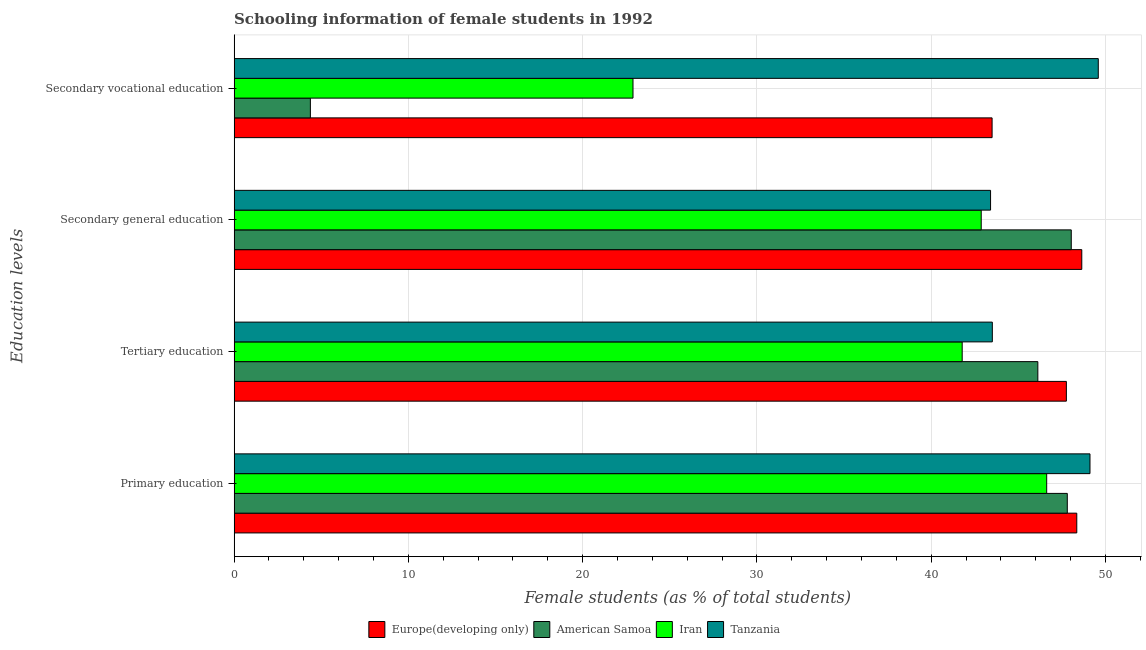How many different coloured bars are there?
Provide a short and direct response. 4. Are the number of bars per tick equal to the number of legend labels?
Give a very brief answer. Yes. What is the label of the 3rd group of bars from the top?
Your answer should be compact. Tertiary education. What is the percentage of female students in tertiary education in Iran?
Your response must be concise. 41.77. Across all countries, what is the maximum percentage of female students in secondary education?
Your answer should be very brief. 48.64. Across all countries, what is the minimum percentage of female students in tertiary education?
Offer a very short reply. 41.77. In which country was the percentage of female students in primary education maximum?
Your answer should be compact. Tanzania. In which country was the percentage of female students in primary education minimum?
Give a very brief answer. Iran. What is the total percentage of female students in tertiary education in the graph?
Ensure brevity in your answer.  179.15. What is the difference between the percentage of female students in tertiary education in Iran and that in American Samoa?
Ensure brevity in your answer.  -4.34. What is the difference between the percentage of female students in tertiary education in Europe(developing only) and the percentage of female students in secondary education in American Samoa?
Give a very brief answer. -0.28. What is the average percentage of female students in secondary education per country?
Keep it short and to the point. 45.73. What is the difference between the percentage of female students in secondary vocational education and percentage of female students in secondary education in Tanzania?
Your answer should be compact. 6.18. What is the ratio of the percentage of female students in secondary education in Iran to that in American Samoa?
Your answer should be very brief. 0.89. Is the percentage of female students in secondary vocational education in Tanzania less than that in American Samoa?
Offer a terse response. No. Is the difference between the percentage of female students in secondary education in American Samoa and Iran greater than the difference between the percentage of female students in secondary vocational education in American Samoa and Iran?
Keep it short and to the point. Yes. What is the difference between the highest and the second highest percentage of female students in secondary vocational education?
Your response must be concise. 6.09. What is the difference between the highest and the lowest percentage of female students in tertiary education?
Your answer should be very brief. 5.98. Is the sum of the percentage of female students in primary education in Iran and American Samoa greater than the maximum percentage of female students in secondary education across all countries?
Provide a succinct answer. Yes. What does the 1st bar from the top in Secondary general education represents?
Make the answer very short. Tanzania. What does the 2nd bar from the bottom in Tertiary education represents?
Provide a succinct answer. American Samoa. Is it the case that in every country, the sum of the percentage of female students in primary education and percentage of female students in tertiary education is greater than the percentage of female students in secondary education?
Provide a short and direct response. Yes. How many bars are there?
Your response must be concise. 16. Are all the bars in the graph horizontal?
Your answer should be very brief. Yes. How many countries are there in the graph?
Your response must be concise. 4. What is the difference between two consecutive major ticks on the X-axis?
Keep it short and to the point. 10. Does the graph contain grids?
Your answer should be compact. Yes. Where does the legend appear in the graph?
Make the answer very short. Bottom center. How many legend labels are there?
Ensure brevity in your answer.  4. What is the title of the graph?
Offer a very short reply. Schooling information of female students in 1992. Does "Cameroon" appear as one of the legend labels in the graph?
Offer a terse response. No. What is the label or title of the X-axis?
Provide a succinct answer. Female students (as % of total students). What is the label or title of the Y-axis?
Provide a succinct answer. Education levels. What is the Female students (as % of total students) of Europe(developing only) in Primary education?
Make the answer very short. 48.35. What is the Female students (as % of total students) in American Samoa in Primary education?
Offer a terse response. 47.81. What is the Female students (as % of total students) in Iran in Primary education?
Your response must be concise. 46.62. What is the Female students (as % of total students) of Tanzania in Primary education?
Offer a very short reply. 49.11. What is the Female students (as % of total students) in Europe(developing only) in Tertiary education?
Make the answer very short. 47.75. What is the Female students (as % of total students) in American Samoa in Tertiary education?
Your answer should be very brief. 46.12. What is the Female students (as % of total students) of Iran in Tertiary education?
Provide a succinct answer. 41.77. What is the Female students (as % of total students) of Tanzania in Tertiary education?
Your answer should be very brief. 43.5. What is the Female students (as % of total students) in Europe(developing only) in Secondary general education?
Offer a terse response. 48.64. What is the Female students (as % of total students) of American Samoa in Secondary general education?
Ensure brevity in your answer.  48.03. What is the Female students (as % of total students) of Iran in Secondary general education?
Your answer should be compact. 42.87. What is the Female students (as % of total students) in Tanzania in Secondary general education?
Offer a very short reply. 43.4. What is the Female students (as % of total students) of Europe(developing only) in Secondary vocational education?
Provide a short and direct response. 43.49. What is the Female students (as % of total students) in American Samoa in Secondary vocational education?
Provide a succinct answer. 4.38. What is the Female students (as % of total students) in Iran in Secondary vocational education?
Make the answer very short. 22.89. What is the Female students (as % of total students) in Tanzania in Secondary vocational education?
Keep it short and to the point. 49.58. Across all Education levels, what is the maximum Female students (as % of total students) in Europe(developing only)?
Ensure brevity in your answer.  48.64. Across all Education levels, what is the maximum Female students (as % of total students) in American Samoa?
Keep it short and to the point. 48.03. Across all Education levels, what is the maximum Female students (as % of total students) in Iran?
Your answer should be compact. 46.62. Across all Education levels, what is the maximum Female students (as % of total students) in Tanzania?
Give a very brief answer. 49.58. Across all Education levels, what is the minimum Female students (as % of total students) in Europe(developing only)?
Provide a succinct answer. 43.49. Across all Education levels, what is the minimum Female students (as % of total students) in American Samoa?
Your answer should be very brief. 4.38. Across all Education levels, what is the minimum Female students (as % of total students) of Iran?
Your answer should be compact. 22.89. Across all Education levels, what is the minimum Female students (as % of total students) in Tanzania?
Offer a very short reply. 43.4. What is the total Female students (as % of total students) in Europe(developing only) in the graph?
Offer a very short reply. 188.23. What is the total Female students (as % of total students) in American Samoa in the graph?
Your answer should be compact. 146.33. What is the total Female students (as % of total students) of Iran in the graph?
Keep it short and to the point. 154.15. What is the total Female students (as % of total students) of Tanzania in the graph?
Offer a terse response. 185.6. What is the difference between the Female students (as % of total students) of Europe(developing only) in Primary education and that in Tertiary education?
Keep it short and to the point. 0.6. What is the difference between the Female students (as % of total students) of American Samoa in Primary education and that in Tertiary education?
Make the answer very short. 1.69. What is the difference between the Female students (as % of total students) in Iran in Primary education and that in Tertiary education?
Offer a very short reply. 4.85. What is the difference between the Female students (as % of total students) in Tanzania in Primary education and that in Tertiary education?
Make the answer very short. 5.6. What is the difference between the Female students (as % of total students) of Europe(developing only) in Primary education and that in Secondary general education?
Make the answer very short. -0.29. What is the difference between the Female students (as % of total students) of American Samoa in Primary education and that in Secondary general education?
Provide a short and direct response. -0.23. What is the difference between the Female students (as % of total students) of Iran in Primary education and that in Secondary general education?
Ensure brevity in your answer.  3.76. What is the difference between the Female students (as % of total students) in Tanzania in Primary education and that in Secondary general education?
Offer a very short reply. 5.71. What is the difference between the Female students (as % of total students) in Europe(developing only) in Primary education and that in Secondary vocational education?
Give a very brief answer. 4.86. What is the difference between the Female students (as % of total students) of American Samoa in Primary education and that in Secondary vocational education?
Provide a succinct answer. 43.43. What is the difference between the Female students (as % of total students) of Iran in Primary education and that in Secondary vocational education?
Offer a terse response. 23.74. What is the difference between the Female students (as % of total students) of Tanzania in Primary education and that in Secondary vocational education?
Offer a very short reply. -0.48. What is the difference between the Female students (as % of total students) of Europe(developing only) in Tertiary education and that in Secondary general education?
Your answer should be very brief. -0.88. What is the difference between the Female students (as % of total students) in American Samoa in Tertiary education and that in Secondary general education?
Offer a very short reply. -1.92. What is the difference between the Female students (as % of total students) in Iran in Tertiary education and that in Secondary general education?
Offer a terse response. -1.09. What is the difference between the Female students (as % of total students) of Tanzania in Tertiary education and that in Secondary general education?
Offer a very short reply. 0.1. What is the difference between the Female students (as % of total students) in Europe(developing only) in Tertiary education and that in Secondary vocational education?
Your answer should be compact. 4.26. What is the difference between the Female students (as % of total students) of American Samoa in Tertiary education and that in Secondary vocational education?
Offer a very short reply. 41.74. What is the difference between the Female students (as % of total students) in Iran in Tertiary education and that in Secondary vocational education?
Your response must be concise. 18.89. What is the difference between the Female students (as % of total students) of Tanzania in Tertiary education and that in Secondary vocational education?
Provide a short and direct response. -6.08. What is the difference between the Female students (as % of total students) in Europe(developing only) in Secondary general education and that in Secondary vocational education?
Provide a succinct answer. 5.15. What is the difference between the Female students (as % of total students) in American Samoa in Secondary general education and that in Secondary vocational education?
Your response must be concise. 43.66. What is the difference between the Female students (as % of total students) of Iran in Secondary general education and that in Secondary vocational education?
Offer a terse response. 19.98. What is the difference between the Female students (as % of total students) of Tanzania in Secondary general education and that in Secondary vocational education?
Offer a very short reply. -6.18. What is the difference between the Female students (as % of total students) in Europe(developing only) in Primary education and the Female students (as % of total students) in American Samoa in Tertiary education?
Offer a very short reply. 2.23. What is the difference between the Female students (as % of total students) in Europe(developing only) in Primary education and the Female students (as % of total students) in Iran in Tertiary education?
Offer a very short reply. 6.57. What is the difference between the Female students (as % of total students) of Europe(developing only) in Primary education and the Female students (as % of total students) of Tanzania in Tertiary education?
Provide a succinct answer. 4.85. What is the difference between the Female students (as % of total students) in American Samoa in Primary education and the Female students (as % of total students) in Iran in Tertiary education?
Offer a very short reply. 6.03. What is the difference between the Female students (as % of total students) of American Samoa in Primary education and the Female students (as % of total students) of Tanzania in Tertiary education?
Your answer should be compact. 4.3. What is the difference between the Female students (as % of total students) of Iran in Primary education and the Female students (as % of total students) of Tanzania in Tertiary education?
Provide a short and direct response. 3.12. What is the difference between the Female students (as % of total students) in Europe(developing only) in Primary education and the Female students (as % of total students) in American Samoa in Secondary general education?
Make the answer very short. 0.32. What is the difference between the Female students (as % of total students) of Europe(developing only) in Primary education and the Female students (as % of total students) of Iran in Secondary general education?
Make the answer very short. 5.48. What is the difference between the Female students (as % of total students) in Europe(developing only) in Primary education and the Female students (as % of total students) in Tanzania in Secondary general education?
Offer a very short reply. 4.95. What is the difference between the Female students (as % of total students) in American Samoa in Primary education and the Female students (as % of total students) in Iran in Secondary general education?
Provide a short and direct response. 4.94. What is the difference between the Female students (as % of total students) of American Samoa in Primary education and the Female students (as % of total students) of Tanzania in Secondary general education?
Your response must be concise. 4.4. What is the difference between the Female students (as % of total students) in Iran in Primary education and the Female students (as % of total students) in Tanzania in Secondary general education?
Offer a terse response. 3.22. What is the difference between the Female students (as % of total students) in Europe(developing only) in Primary education and the Female students (as % of total students) in American Samoa in Secondary vocational education?
Give a very brief answer. 43.97. What is the difference between the Female students (as % of total students) of Europe(developing only) in Primary education and the Female students (as % of total students) of Iran in Secondary vocational education?
Ensure brevity in your answer.  25.46. What is the difference between the Female students (as % of total students) in Europe(developing only) in Primary education and the Female students (as % of total students) in Tanzania in Secondary vocational education?
Offer a terse response. -1.23. What is the difference between the Female students (as % of total students) of American Samoa in Primary education and the Female students (as % of total students) of Iran in Secondary vocational education?
Give a very brief answer. 24.92. What is the difference between the Female students (as % of total students) of American Samoa in Primary education and the Female students (as % of total students) of Tanzania in Secondary vocational education?
Keep it short and to the point. -1.78. What is the difference between the Female students (as % of total students) of Iran in Primary education and the Female students (as % of total students) of Tanzania in Secondary vocational education?
Offer a terse response. -2.96. What is the difference between the Female students (as % of total students) in Europe(developing only) in Tertiary education and the Female students (as % of total students) in American Samoa in Secondary general education?
Offer a terse response. -0.28. What is the difference between the Female students (as % of total students) in Europe(developing only) in Tertiary education and the Female students (as % of total students) in Iran in Secondary general education?
Offer a terse response. 4.89. What is the difference between the Female students (as % of total students) in Europe(developing only) in Tertiary education and the Female students (as % of total students) in Tanzania in Secondary general education?
Your answer should be compact. 4.35. What is the difference between the Female students (as % of total students) in American Samoa in Tertiary education and the Female students (as % of total students) in Iran in Secondary general education?
Give a very brief answer. 3.25. What is the difference between the Female students (as % of total students) in American Samoa in Tertiary education and the Female students (as % of total students) in Tanzania in Secondary general education?
Make the answer very short. 2.71. What is the difference between the Female students (as % of total students) in Iran in Tertiary education and the Female students (as % of total students) in Tanzania in Secondary general education?
Offer a very short reply. -1.63. What is the difference between the Female students (as % of total students) of Europe(developing only) in Tertiary education and the Female students (as % of total students) of American Samoa in Secondary vocational education?
Provide a short and direct response. 43.38. What is the difference between the Female students (as % of total students) of Europe(developing only) in Tertiary education and the Female students (as % of total students) of Iran in Secondary vocational education?
Provide a succinct answer. 24.87. What is the difference between the Female students (as % of total students) of Europe(developing only) in Tertiary education and the Female students (as % of total students) of Tanzania in Secondary vocational education?
Give a very brief answer. -1.83. What is the difference between the Female students (as % of total students) of American Samoa in Tertiary education and the Female students (as % of total students) of Iran in Secondary vocational education?
Ensure brevity in your answer.  23.23. What is the difference between the Female students (as % of total students) of American Samoa in Tertiary education and the Female students (as % of total students) of Tanzania in Secondary vocational education?
Give a very brief answer. -3.47. What is the difference between the Female students (as % of total students) in Iran in Tertiary education and the Female students (as % of total students) in Tanzania in Secondary vocational education?
Your answer should be very brief. -7.81. What is the difference between the Female students (as % of total students) in Europe(developing only) in Secondary general education and the Female students (as % of total students) in American Samoa in Secondary vocational education?
Keep it short and to the point. 44.26. What is the difference between the Female students (as % of total students) in Europe(developing only) in Secondary general education and the Female students (as % of total students) in Iran in Secondary vocational education?
Give a very brief answer. 25.75. What is the difference between the Female students (as % of total students) of Europe(developing only) in Secondary general education and the Female students (as % of total students) of Tanzania in Secondary vocational education?
Make the answer very short. -0.95. What is the difference between the Female students (as % of total students) in American Samoa in Secondary general education and the Female students (as % of total students) in Iran in Secondary vocational education?
Offer a terse response. 25.15. What is the difference between the Female students (as % of total students) in American Samoa in Secondary general education and the Female students (as % of total students) in Tanzania in Secondary vocational education?
Your answer should be very brief. -1.55. What is the difference between the Female students (as % of total students) in Iran in Secondary general education and the Female students (as % of total students) in Tanzania in Secondary vocational education?
Your answer should be compact. -6.72. What is the average Female students (as % of total students) in Europe(developing only) per Education levels?
Give a very brief answer. 47.06. What is the average Female students (as % of total students) of American Samoa per Education levels?
Provide a succinct answer. 36.58. What is the average Female students (as % of total students) of Iran per Education levels?
Provide a succinct answer. 38.54. What is the average Female students (as % of total students) of Tanzania per Education levels?
Your answer should be compact. 46.4. What is the difference between the Female students (as % of total students) in Europe(developing only) and Female students (as % of total students) in American Samoa in Primary education?
Offer a very short reply. 0.54. What is the difference between the Female students (as % of total students) of Europe(developing only) and Female students (as % of total students) of Iran in Primary education?
Provide a succinct answer. 1.73. What is the difference between the Female students (as % of total students) of Europe(developing only) and Female students (as % of total students) of Tanzania in Primary education?
Give a very brief answer. -0.76. What is the difference between the Female students (as % of total students) in American Samoa and Female students (as % of total students) in Iran in Primary education?
Your answer should be compact. 1.18. What is the difference between the Female students (as % of total students) in American Samoa and Female students (as % of total students) in Tanzania in Primary education?
Offer a very short reply. -1.3. What is the difference between the Female students (as % of total students) of Iran and Female students (as % of total students) of Tanzania in Primary education?
Provide a succinct answer. -2.48. What is the difference between the Female students (as % of total students) of Europe(developing only) and Female students (as % of total students) of American Samoa in Tertiary education?
Ensure brevity in your answer.  1.64. What is the difference between the Female students (as % of total students) of Europe(developing only) and Female students (as % of total students) of Iran in Tertiary education?
Make the answer very short. 5.98. What is the difference between the Female students (as % of total students) in Europe(developing only) and Female students (as % of total students) in Tanzania in Tertiary education?
Your response must be concise. 4.25. What is the difference between the Female students (as % of total students) in American Samoa and Female students (as % of total students) in Iran in Tertiary education?
Give a very brief answer. 4.34. What is the difference between the Female students (as % of total students) in American Samoa and Female students (as % of total students) in Tanzania in Tertiary education?
Your answer should be compact. 2.61. What is the difference between the Female students (as % of total students) in Iran and Female students (as % of total students) in Tanzania in Tertiary education?
Make the answer very short. -1.73. What is the difference between the Female students (as % of total students) in Europe(developing only) and Female students (as % of total students) in American Samoa in Secondary general education?
Offer a very short reply. 0.6. What is the difference between the Female students (as % of total students) of Europe(developing only) and Female students (as % of total students) of Iran in Secondary general education?
Give a very brief answer. 5.77. What is the difference between the Female students (as % of total students) of Europe(developing only) and Female students (as % of total students) of Tanzania in Secondary general education?
Your answer should be very brief. 5.23. What is the difference between the Female students (as % of total students) of American Samoa and Female students (as % of total students) of Iran in Secondary general education?
Offer a terse response. 5.17. What is the difference between the Female students (as % of total students) in American Samoa and Female students (as % of total students) in Tanzania in Secondary general education?
Offer a terse response. 4.63. What is the difference between the Female students (as % of total students) in Iran and Female students (as % of total students) in Tanzania in Secondary general education?
Provide a succinct answer. -0.54. What is the difference between the Female students (as % of total students) of Europe(developing only) and Female students (as % of total students) of American Samoa in Secondary vocational education?
Provide a succinct answer. 39.12. What is the difference between the Female students (as % of total students) of Europe(developing only) and Female students (as % of total students) of Iran in Secondary vocational education?
Keep it short and to the point. 20.6. What is the difference between the Female students (as % of total students) of Europe(developing only) and Female students (as % of total students) of Tanzania in Secondary vocational education?
Ensure brevity in your answer.  -6.09. What is the difference between the Female students (as % of total students) of American Samoa and Female students (as % of total students) of Iran in Secondary vocational education?
Your answer should be compact. -18.51. What is the difference between the Female students (as % of total students) in American Samoa and Female students (as % of total students) in Tanzania in Secondary vocational education?
Offer a terse response. -45.21. What is the difference between the Female students (as % of total students) of Iran and Female students (as % of total students) of Tanzania in Secondary vocational education?
Offer a terse response. -26.7. What is the ratio of the Female students (as % of total students) of Europe(developing only) in Primary education to that in Tertiary education?
Give a very brief answer. 1.01. What is the ratio of the Female students (as % of total students) of American Samoa in Primary education to that in Tertiary education?
Provide a succinct answer. 1.04. What is the ratio of the Female students (as % of total students) in Iran in Primary education to that in Tertiary education?
Keep it short and to the point. 1.12. What is the ratio of the Female students (as % of total students) of Tanzania in Primary education to that in Tertiary education?
Your answer should be compact. 1.13. What is the ratio of the Female students (as % of total students) of Europe(developing only) in Primary education to that in Secondary general education?
Provide a succinct answer. 0.99. What is the ratio of the Female students (as % of total students) in American Samoa in Primary education to that in Secondary general education?
Ensure brevity in your answer.  1. What is the ratio of the Female students (as % of total students) of Iran in Primary education to that in Secondary general education?
Give a very brief answer. 1.09. What is the ratio of the Female students (as % of total students) in Tanzania in Primary education to that in Secondary general education?
Ensure brevity in your answer.  1.13. What is the ratio of the Female students (as % of total students) of Europe(developing only) in Primary education to that in Secondary vocational education?
Keep it short and to the point. 1.11. What is the ratio of the Female students (as % of total students) in American Samoa in Primary education to that in Secondary vocational education?
Offer a terse response. 10.93. What is the ratio of the Female students (as % of total students) of Iran in Primary education to that in Secondary vocational education?
Your response must be concise. 2.04. What is the ratio of the Female students (as % of total students) in Tanzania in Primary education to that in Secondary vocational education?
Keep it short and to the point. 0.99. What is the ratio of the Female students (as % of total students) in Europe(developing only) in Tertiary education to that in Secondary general education?
Offer a terse response. 0.98. What is the ratio of the Female students (as % of total students) of American Samoa in Tertiary education to that in Secondary general education?
Keep it short and to the point. 0.96. What is the ratio of the Female students (as % of total students) of Iran in Tertiary education to that in Secondary general education?
Offer a very short reply. 0.97. What is the ratio of the Female students (as % of total students) of Tanzania in Tertiary education to that in Secondary general education?
Your answer should be very brief. 1. What is the ratio of the Female students (as % of total students) in Europe(developing only) in Tertiary education to that in Secondary vocational education?
Provide a short and direct response. 1.1. What is the ratio of the Female students (as % of total students) in American Samoa in Tertiary education to that in Secondary vocational education?
Your response must be concise. 10.54. What is the ratio of the Female students (as % of total students) in Iran in Tertiary education to that in Secondary vocational education?
Keep it short and to the point. 1.83. What is the ratio of the Female students (as % of total students) of Tanzania in Tertiary education to that in Secondary vocational education?
Provide a short and direct response. 0.88. What is the ratio of the Female students (as % of total students) of Europe(developing only) in Secondary general education to that in Secondary vocational education?
Keep it short and to the point. 1.12. What is the ratio of the Female students (as % of total students) of American Samoa in Secondary general education to that in Secondary vocational education?
Ensure brevity in your answer.  10.98. What is the ratio of the Female students (as % of total students) of Iran in Secondary general education to that in Secondary vocational education?
Offer a very short reply. 1.87. What is the ratio of the Female students (as % of total students) in Tanzania in Secondary general education to that in Secondary vocational education?
Make the answer very short. 0.88. What is the difference between the highest and the second highest Female students (as % of total students) of Europe(developing only)?
Your answer should be very brief. 0.29. What is the difference between the highest and the second highest Female students (as % of total students) in American Samoa?
Ensure brevity in your answer.  0.23. What is the difference between the highest and the second highest Female students (as % of total students) in Iran?
Keep it short and to the point. 3.76. What is the difference between the highest and the second highest Female students (as % of total students) of Tanzania?
Offer a very short reply. 0.48. What is the difference between the highest and the lowest Female students (as % of total students) in Europe(developing only)?
Provide a short and direct response. 5.15. What is the difference between the highest and the lowest Female students (as % of total students) in American Samoa?
Give a very brief answer. 43.66. What is the difference between the highest and the lowest Female students (as % of total students) in Iran?
Your response must be concise. 23.74. What is the difference between the highest and the lowest Female students (as % of total students) in Tanzania?
Provide a short and direct response. 6.18. 